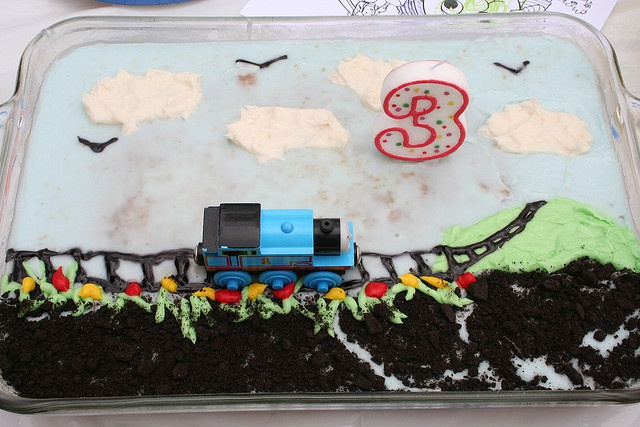Describe the objects in this image and their specific colors. I can see cake in lightgray, black, darkgray, and lightgreen tones, train in lightgray, black, gray, lightblue, and blue tones, bird in lightgray, black, gray, and darkgray tones, bird in lightgray, black, gray, and darkgray tones, and bird in lightgray, darkgray, gray, and black tones in this image. 